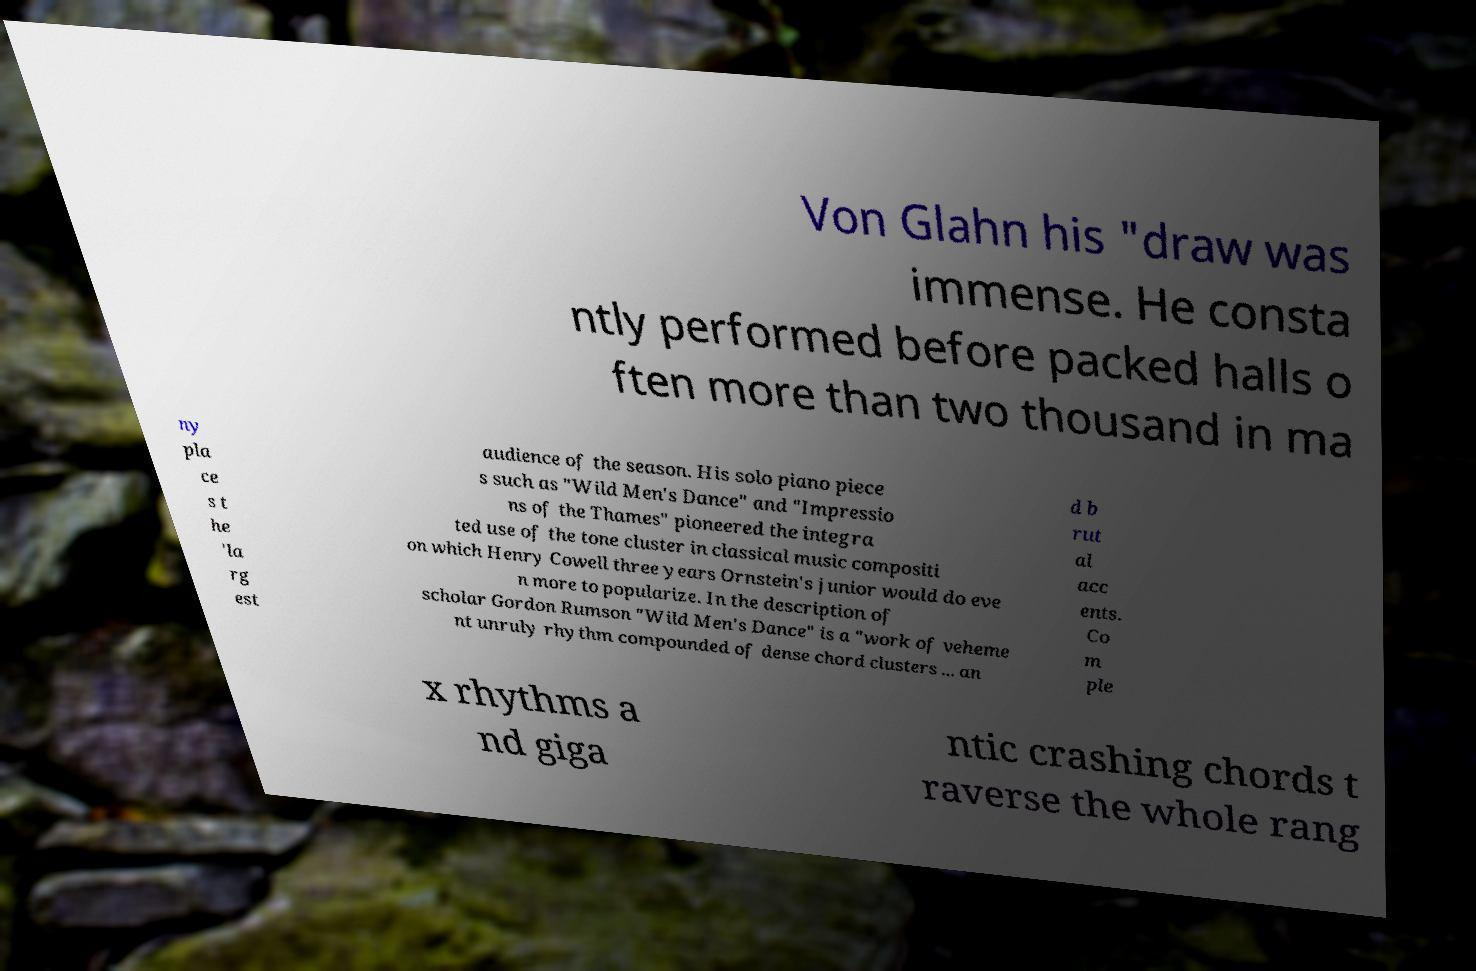Can you read and provide the text displayed in the image?This photo seems to have some interesting text. Can you extract and type it out for me? Von Glahn his "draw was immense. He consta ntly performed before packed halls o ften more than two thousand in ma ny pla ce s t he 'la rg est audience of the season. His solo piano piece s such as "Wild Men's Dance" and "Impressio ns of the Thames" pioneered the integra ted use of the tone cluster in classical music compositi on which Henry Cowell three years Ornstein's junior would do eve n more to popularize. In the description of scholar Gordon Rumson "Wild Men's Dance" is a "work of veheme nt unruly rhythm compounded of dense chord clusters ... an d b rut al acc ents. Co m ple x rhythms a nd giga ntic crashing chords t raverse the whole rang 